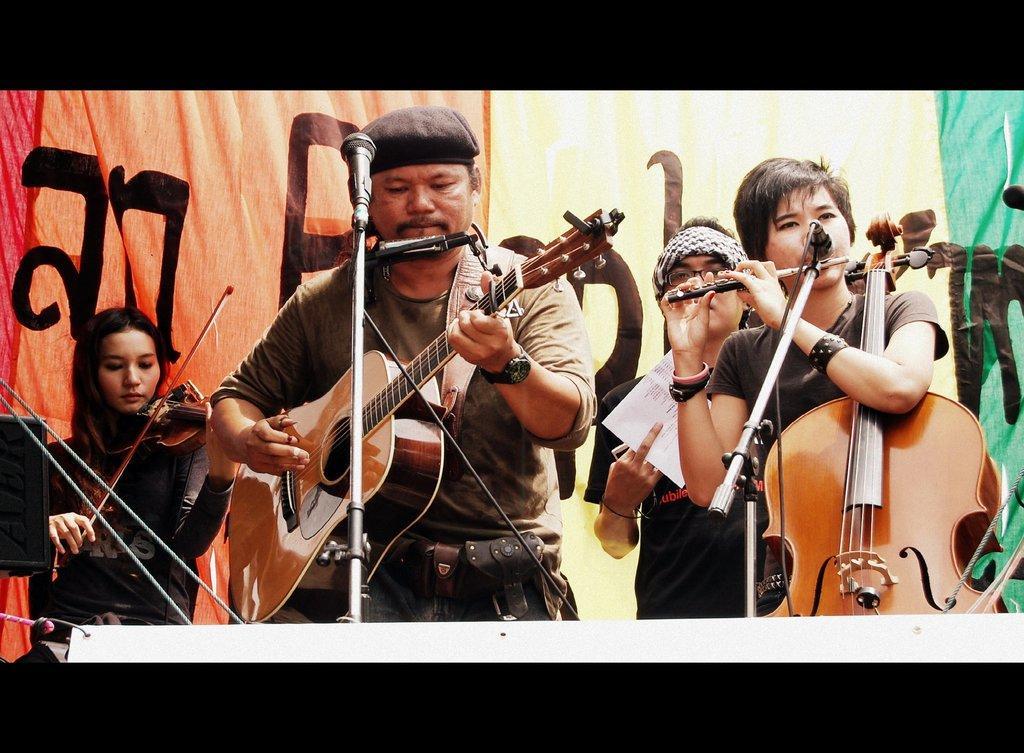Could you give a brief overview of what you see in this image? There are few musicians in the image and everyone is standing. The woman to the left is playing violin and the man in the center wore a cap and is playing guitar. The woman at the right is holding a violin and playing a flute. The man behind her is holding paper in his hand. There are microphones with stands in front of them. In the background there is a banner. 